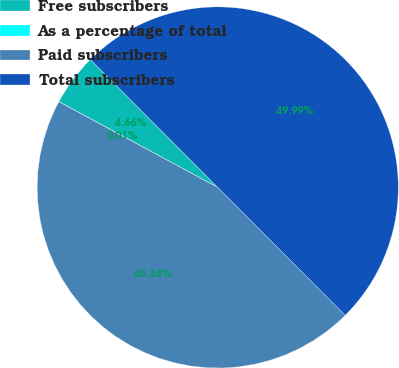Convert chart. <chart><loc_0><loc_0><loc_500><loc_500><pie_chart><fcel>Free subscribers<fcel>As a percentage of total<fcel>Paid subscribers<fcel>Total subscribers<nl><fcel>4.66%<fcel>0.01%<fcel>45.34%<fcel>49.99%<nl></chart> 